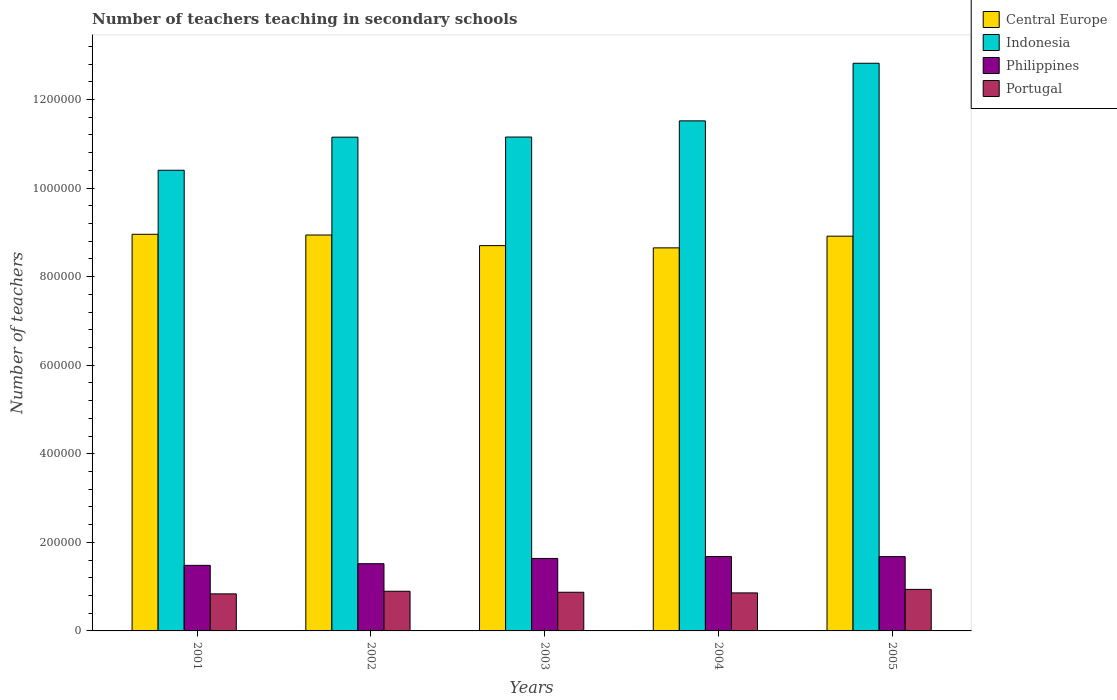How many different coloured bars are there?
Keep it short and to the point. 4. How many groups of bars are there?
Keep it short and to the point. 5. Are the number of bars per tick equal to the number of legend labels?
Your response must be concise. Yes. How many bars are there on the 1st tick from the left?
Give a very brief answer. 4. What is the number of teachers teaching in secondary schools in Indonesia in 2002?
Offer a terse response. 1.11e+06. Across all years, what is the maximum number of teachers teaching in secondary schools in Indonesia?
Your response must be concise. 1.28e+06. Across all years, what is the minimum number of teachers teaching in secondary schools in Philippines?
Keep it short and to the point. 1.48e+05. In which year was the number of teachers teaching in secondary schools in Portugal maximum?
Your answer should be very brief. 2005. In which year was the number of teachers teaching in secondary schools in Portugal minimum?
Your response must be concise. 2001. What is the total number of teachers teaching in secondary schools in Indonesia in the graph?
Make the answer very short. 5.70e+06. What is the difference between the number of teachers teaching in secondary schools in Philippines in 2003 and that in 2004?
Your answer should be compact. -4412. What is the difference between the number of teachers teaching in secondary schools in Philippines in 2003 and the number of teachers teaching in secondary schools in Indonesia in 2001?
Ensure brevity in your answer.  -8.76e+05. What is the average number of teachers teaching in secondary schools in Central Europe per year?
Provide a short and direct response. 8.83e+05. In the year 2001, what is the difference between the number of teachers teaching in secondary schools in Philippines and number of teachers teaching in secondary schools in Portugal?
Your answer should be compact. 6.44e+04. What is the ratio of the number of teachers teaching in secondary schools in Central Europe in 2001 to that in 2002?
Your response must be concise. 1. What is the difference between the highest and the second highest number of teachers teaching in secondary schools in Philippines?
Your answer should be compact. 309. What is the difference between the highest and the lowest number of teachers teaching in secondary schools in Indonesia?
Ensure brevity in your answer.  2.42e+05. In how many years, is the number of teachers teaching in secondary schools in Central Europe greater than the average number of teachers teaching in secondary schools in Central Europe taken over all years?
Ensure brevity in your answer.  3. What does the 1st bar from the left in 2005 represents?
Give a very brief answer. Central Europe. Is it the case that in every year, the sum of the number of teachers teaching in secondary schools in Portugal and number of teachers teaching in secondary schools in Philippines is greater than the number of teachers teaching in secondary schools in Central Europe?
Your response must be concise. No. Are all the bars in the graph horizontal?
Your response must be concise. No. Are the values on the major ticks of Y-axis written in scientific E-notation?
Offer a very short reply. No. Does the graph contain grids?
Make the answer very short. No. How many legend labels are there?
Offer a terse response. 4. What is the title of the graph?
Give a very brief answer. Number of teachers teaching in secondary schools. What is the label or title of the Y-axis?
Offer a very short reply. Number of teachers. What is the Number of teachers in Central Europe in 2001?
Offer a terse response. 8.96e+05. What is the Number of teachers of Indonesia in 2001?
Your answer should be compact. 1.04e+06. What is the Number of teachers in Philippines in 2001?
Your response must be concise. 1.48e+05. What is the Number of teachers in Portugal in 2001?
Offer a very short reply. 8.37e+04. What is the Number of teachers of Central Europe in 2002?
Your answer should be compact. 8.94e+05. What is the Number of teachers in Indonesia in 2002?
Offer a very short reply. 1.11e+06. What is the Number of teachers in Philippines in 2002?
Keep it short and to the point. 1.52e+05. What is the Number of teachers in Portugal in 2002?
Provide a short and direct response. 8.96e+04. What is the Number of teachers in Central Europe in 2003?
Your response must be concise. 8.70e+05. What is the Number of teachers of Indonesia in 2003?
Your answer should be very brief. 1.12e+06. What is the Number of teachers in Philippines in 2003?
Your answer should be very brief. 1.64e+05. What is the Number of teachers of Portugal in 2003?
Your answer should be very brief. 8.73e+04. What is the Number of teachers in Central Europe in 2004?
Offer a very short reply. 8.65e+05. What is the Number of teachers in Indonesia in 2004?
Provide a succinct answer. 1.15e+06. What is the Number of teachers of Philippines in 2004?
Offer a terse response. 1.68e+05. What is the Number of teachers in Portugal in 2004?
Your answer should be compact. 8.59e+04. What is the Number of teachers in Central Europe in 2005?
Ensure brevity in your answer.  8.91e+05. What is the Number of teachers of Indonesia in 2005?
Offer a very short reply. 1.28e+06. What is the Number of teachers in Philippines in 2005?
Make the answer very short. 1.68e+05. What is the Number of teachers of Portugal in 2005?
Keep it short and to the point. 9.38e+04. Across all years, what is the maximum Number of teachers in Central Europe?
Give a very brief answer. 8.96e+05. Across all years, what is the maximum Number of teachers of Indonesia?
Provide a succinct answer. 1.28e+06. Across all years, what is the maximum Number of teachers of Philippines?
Your response must be concise. 1.68e+05. Across all years, what is the maximum Number of teachers in Portugal?
Provide a short and direct response. 9.38e+04. Across all years, what is the minimum Number of teachers in Central Europe?
Give a very brief answer. 8.65e+05. Across all years, what is the minimum Number of teachers in Indonesia?
Offer a terse response. 1.04e+06. Across all years, what is the minimum Number of teachers of Philippines?
Make the answer very short. 1.48e+05. Across all years, what is the minimum Number of teachers of Portugal?
Offer a terse response. 8.37e+04. What is the total Number of teachers of Central Europe in the graph?
Give a very brief answer. 4.42e+06. What is the total Number of teachers in Indonesia in the graph?
Keep it short and to the point. 5.70e+06. What is the total Number of teachers of Philippines in the graph?
Provide a short and direct response. 7.99e+05. What is the total Number of teachers of Portugal in the graph?
Your answer should be compact. 4.40e+05. What is the difference between the Number of teachers in Central Europe in 2001 and that in 2002?
Your response must be concise. 1627.56. What is the difference between the Number of teachers of Indonesia in 2001 and that in 2002?
Your answer should be compact. -7.47e+04. What is the difference between the Number of teachers of Philippines in 2001 and that in 2002?
Provide a succinct answer. -3717. What is the difference between the Number of teachers of Portugal in 2001 and that in 2002?
Offer a very short reply. -5935. What is the difference between the Number of teachers in Central Europe in 2001 and that in 2003?
Ensure brevity in your answer.  2.56e+04. What is the difference between the Number of teachers of Indonesia in 2001 and that in 2003?
Offer a very short reply. -7.50e+04. What is the difference between the Number of teachers in Philippines in 2001 and that in 2003?
Offer a very short reply. -1.56e+04. What is the difference between the Number of teachers of Portugal in 2001 and that in 2003?
Ensure brevity in your answer.  -3651. What is the difference between the Number of teachers in Central Europe in 2001 and that in 2004?
Offer a very short reply. 3.07e+04. What is the difference between the Number of teachers in Indonesia in 2001 and that in 2004?
Provide a short and direct response. -1.12e+05. What is the difference between the Number of teachers of Philippines in 2001 and that in 2004?
Provide a short and direct response. -2.00e+04. What is the difference between the Number of teachers of Portugal in 2001 and that in 2004?
Offer a terse response. -2207. What is the difference between the Number of teachers in Central Europe in 2001 and that in 2005?
Ensure brevity in your answer.  4228.88. What is the difference between the Number of teachers of Indonesia in 2001 and that in 2005?
Offer a very short reply. -2.42e+05. What is the difference between the Number of teachers in Philippines in 2001 and that in 2005?
Your answer should be very brief. -1.97e+04. What is the difference between the Number of teachers of Portugal in 2001 and that in 2005?
Offer a very short reply. -1.02e+04. What is the difference between the Number of teachers in Central Europe in 2002 and that in 2003?
Provide a short and direct response. 2.40e+04. What is the difference between the Number of teachers in Indonesia in 2002 and that in 2003?
Keep it short and to the point. -300. What is the difference between the Number of teachers of Philippines in 2002 and that in 2003?
Your response must be concise. -1.19e+04. What is the difference between the Number of teachers of Portugal in 2002 and that in 2003?
Your answer should be very brief. 2284. What is the difference between the Number of teachers of Central Europe in 2002 and that in 2004?
Make the answer very short. 2.90e+04. What is the difference between the Number of teachers of Indonesia in 2002 and that in 2004?
Your answer should be very brief. -3.68e+04. What is the difference between the Number of teachers of Philippines in 2002 and that in 2004?
Give a very brief answer. -1.63e+04. What is the difference between the Number of teachers of Portugal in 2002 and that in 2004?
Provide a succinct answer. 3728. What is the difference between the Number of teachers of Central Europe in 2002 and that in 2005?
Keep it short and to the point. 2601.31. What is the difference between the Number of teachers of Indonesia in 2002 and that in 2005?
Keep it short and to the point. -1.67e+05. What is the difference between the Number of teachers of Philippines in 2002 and that in 2005?
Your response must be concise. -1.60e+04. What is the difference between the Number of teachers of Portugal in 2002 and that in 2005?
Provide a succinct answer. -4217. What is the difference between the Number of teachers in Central Europe in 2003 and that in 2004?
Make the answer very short. 5052.31. What is the difference between the Number of teachers of Indonesia in 2003 and that in 2004?
Your answer should be compact. -3.65e+04. What is the difference between the Number of teachers of Philippines in 2003 and that in 2004?
Keep it short and to the point. -4412. What is the difference between the Number of teachers in Portugal in 2003 and that in 2004?
Your answer should be very brief. 1444. What is the difference between the Number of teachers of Central Europe in 2003 and that in 2005?
Keep it short and to the point. -2.14e+04. What is the difference between the Number of teachers in Indonesia in 2003 and that in 2005?
Provide a short and direct response. -1.67e+05. What is the difference between the Number of teachers of Philippines in 2003 and that in 2005?
Offer a terse response. -4103. What is the difference between the Number of teachers of Portugal in 2003 and that in 2005?
Offer a terse response. -6501. What is the difference between the Number of teachers in Central Europe in 2004 and that in 2005?
Your response must be concise. -2.64e+04. What is the difference between the Number of teachers of Indonesia in 2004 and that in 2005?
Your answer should be very brief. -1.30e+05. What is the difference between the Number of teachers of Philippines in 2004 and that in 2005?
Provide a short and direct response. 309. What is the difference between the Number of teachers in Portugal in 2004 and that in 2005?
Offer a very short reply. -7945. What is the difference between the Number of teachers of Central Europe in 2001 and the Number of teachers of Indonesia in 2002?
Provide a succinct answer. -2.19e+05. What is the difference between the Number of teachers in Central Europe in 2001 and the Number of teachers in Philippines in 2002?
Provide a succinct answer. 7.44e+05. What is the difference between the Number of teachers in Central Europe in 2001 and the Number of teachers in Portugal in 2002?
Provide a succinct answer. 8.06e+05. What is the difference between the Number of teachers of Indonesia in 2001 and the Number of teachers of Philippines in 2002?
Ensure brevity in your answer.  8.88e+05. What is the difference between the Number of teachers in Indonesia in 2001 and the Number of teachers in Portugal in 2002?
Offer a very short reply. 9.50e+05. What is the difference between the Number of teachers of Philippines in 2001 and the Number of teachers of Portugal in 2002?
Offer a very short reply. 5.84e+04. What is the difference between the Number of teachers in Central Europe in 2001 and the Number of teachers in Indonesia in 2003?
Your response must be concise. -2.20e+05. What is the difference between the Number of teachers in Central Europe in 2001 and the Number of teachers in Philippines in 2003?
Your answer should be compact. 7.32e+05. What is the difference between the Number of teachers of Central Europe in 2001 and the Number of teachers of Portugal in 2003?
Keep it short and to the point. 8.08e+05. What is the difference between the Number of teachers of Indonesia in 2001 and the Number of teachers of Philippines in 2003?
Provide a short and direct response. 8.76e+05. What is the difference between the Number of teachers in Indonesia in 2001 and the Number of teachers in Portugal in 2003?
Keep it short and to the point. 9.53e+05. What is the difference between the Number of teachers of Philippines in 2001 and the Number of teachers of Portugal in 2003?
Your answer should be very brief. 6.07e+04. What is the difference between the Number of teachers in Central Europe in 2001 and the Number of teachers in Indonesia in 2004?
Ensure brevity in your answer.  -2.56e+05. What is the difference between the Number of teachers of Central Europe in 2001 and the Number of teachers of Philippines in 2004?
Give a very brief answer. 7.27e+05. What is the difference between the Number of teachers of Central Europe in 2001 and the Number of teachers of Portugal in 2004?
Your answer should be very brief. 8.10e+05. What is the difference between the Number of teachers in Indonesia in 2001 and the Number of teachers in Philippines in 2004?
Your answer should be compact. 8.72e+05. What is the difference between the Number of teachers of Indonesia in 2001 and the Number of teachers of Portugal in 2004?
Ensure brevity in your answer.  9.54e+05. What is the difference between the Number of teachers of Philippines in 2001 and the Number of teachers of Portugal in 2004?
Keep it short and to the point. 6.22e+04. What is the difference between the Number of teachers of Central Europe in 2001 and the Number of teachers of Indonesia in 2005?
Your answer should be very brief. -3.86e+05. What is the difference between the Number of teachers of Central Europe in 2001 and the Number of teachers of Philippines in 2005?
Ensure brevity in your answer.  7.28e+05. What is the difference between the Number of teachers of Central Europe in 2001 and the Number of teachers of Portugal in 2005?
Give a very brief answer. 8.02e+05. What is the difference between the Number of teachers of Indonesia in 2001 and the Number of teachers of Philippines in 2005?
Provide a short and direct response. 8.72e+05. What is the difference between the Number of teachers of Indonesia in 2001 and the Number of teachers of Portugal in 2005?
Your answer should be compact. 9.46e+05. What is the difference between the Number of teachers of Philippines in 2001 and the Number of teachers of Portugal in 2005?
Make the answer very short. 5.42e+04. What is the difference between the Number of teachers of Central Europe in 2002 and the Number of teachers of Indonesia in 2003?
Offer a terse response. -2.21e+05. What is the difference between the Number of teachers in Central Europe in 2002 and the Number of teachers in Philippines in 2003?
Offer a terse response. 7.30e+05. What is the difference between the Number of teachers of Central Europe in 2002 and the Number of teachers of Portugal in 2003?
Offer a very short reply. 8.07e+05. What is the difference between the Number of teachers of Indonesia in 2002 and the Number of teachers of Philippines in 2003?
Provide a succinct answer. 9.51e+05. What is the difference between the Number of teachers in Indonesia in 2002 and the Number of teachers in Portugal in 2003?
Offer a terse response. 1.03e+06. What is the difference between the Number of teachers in Philippines in 2002 and the Number of teachers in Portugal in 2003?
Provide a short and direct response. 6.44e+04. What is the difference between the Number of teachers in Central Europe in 2002 and the Number of teachers in Indonesia in 2004?
Provide a short and direct response. -2.58e+05. What is the difference between the Number of teachers in Central Europe in 2002 and the Number of teachers in Philippines in 2004?
Ensure brevity in your answer.  7.26e+05. What is the difference between the Number of teachers of Central Europe in 2002 and the Number of teachers of Portugal in 2004?
Offer a terse response. 8.08e+05. What is the difference between the Number of teachers of Indonesia in 2002 and the Number of teachers of Philippines in 2004?
Offer a very short reply. 9.47e+05. What is the difference between the Number of teachers in Indonesia in 2002 and the Number of teachers in Portugal in 2004?
Make the answer very short. 1.03e+06. What is the difference between the Number of teachers in Philippines in 2002 and the Number of teachers in Portugal in 2004?
Give a very brief answer. 6.59e+04. What is the difference between the Number of teachers in Central Europe in 2002 and the Number of teachers in Indonesia in 2005?
Your answer should be very brief. -3.88e+05. What is the difference between the Number of teachers of Central Europe in 2002 and the Number of teachers of Philippines in 2005?
Give a very brief answer. 7.26e+05. What is the difference between the Number of teachers of Central Europe in 2002 and the Number of teachers of Portugal in 2005?
Your response must be concise. 8.00e+05. What is the difference between the Number of teachers in Indonesia in 2002 and the Number of teachers in Philippines in 2005?
Your answer should be compact. 9.47e+05. What is the difference between the Number of teachers in Indonesia in 2002 and the Number of teachers in Portugal in 2005?
Offer a very short reply. 1.02e+06. What is the difference between the Number of teachers in Philippines in 2002 and the Number of teachers in Portugal in 2005?
Provide a succinct answer. 5.79e+04. What is the difference between the Number of teachers in Central Europe in 2003 and the Number of teachers in Indonesia in 2004?
Give a very brief answer. -2.82e+05. What is the difference between the Number of teachers in Central Europe in 2003 and the Number of teachers in Philippines in 2004?
Make the answer very short. 7.02e+05. What is the difference between the Number of teachers of Central Europe in 2003 and the Number of teachers of Portugal in 2004?
Ensure brevity in your answer.  7.84e+05. What is the difference between the Number of teachers in Indonesia in 2003 and the Number of teachers in Philippines in 2004?
Offer a terse response. 9.47e+05. What is the difference between the Number of teachers in Indonesia in 2003 and the Number of teachers in Portugal in 2004?
Your answer should be very brief. 1.03e+06. What is the difference between the Number of teachers in Philippines in 2003 and the Number of teachers in Portugal in 2004?
Give a very brief answer. 7.78e+04. What is the difference between the Number of teachers in Central Europe in 2003 and the Number of teachers in Indonesia in 2005?
Make the answer very short. -4.12e+05. What is the difference between the Number of teachers of Central Europe in 2003 and the Number of teachers of Philippines in 2005?
Your response must be concise. 7.02e+05. What is the difference between the Number of teachers of Central Europe in 2003 and the Number of teachers of Portugal in 2005?
Provide a succinct answer. 7.76e+05. What is the difference between the Number of teachers in Indonesia in 2003 and the Number of teachers in Philippines in 2005?
Offer a terse response. 9.47e+05. What is the difference between the Number of teachers of Indonesia in 2003 and the Number of teachers of Portugal in 2005?
Offer a terse response. 1.02e+06. What is the difference between the Number of teachers of Philippines in 2003 and the Number of teachers of Portugal in 2005?
Provide a short and direct response. 6.98e+04. What is the difference between the Number of teachers of Central Europe in 2004 and the Number of teachers of Indonesia in 2005?
Provide a succinct answer. -4.17e+05. What is the difference between the Number of teachers of Central Europe in 2004 and the Number of teachers of Philippines in 2005?
Your answer should be very brief. 6.97e+05. What is the difference between the Number of teachers in Central Europe in 2004 and the Number of teachers in Portugal in 2005?
Keep it short and to the point. 7.71e+05. What is the difference between the Number of teachers of Indonesia in 2004 and the Number of teachers of Philippines in 2005?
Your answer should be very brief. 9.84e+05. What is the difference between the Number of teachers in Indonesia in 2004 and the Number of teachers in Portugal in 2005?
Your answer should be very brief. 1.06e+06. What is the difference between the Number of teachers of Philippines in 2004 and the Number of teachers of Portugal in 2005?
Offer a terse response. 7.43e+04. What is the average Number of teachers in Central Europe per year?
Offer a terse response. 8.83e+05. What is the average Number of teachers of Indonesia per year?
Your response must be concise. 1.14e+06. What is the average Number of teachers of Philippines per year?
Your response must be concise. 1.60e+05. What is the average Number of teachers of Portugal per year?
Ensure brevity in your answer.  8.80e+04. In the year 2001, what is the difference between the Number of teachers in Central Europe and Number of teachers in Indonesia?
Offer a terse response. -1.45e+05. In the year 2001, what is the difference between the Number of teachers of Central Europe and Number of teachers of Philippines?
Your answer should be compact. 7.47e+05. In the year 2001, what is the difference between the Number of teachers of Central Europe and Number of teachers of Portugal?
Ensure brevity in your answer.  8.12e+05. In the year 2001, what is the difference between the Number of teachers in Indonesia and Number of teachers in Philippines?
Make the answer very short. 8.92e+05. In the year 2001, what is the difference between the Number of teachers in Indonesia and Number of teachers in Portugal?
Ensure brevity in your answer.  9.56e+05. In the year 2001, what is the difference between the Number of teachers in Philippines and Number of teachers in Portugal?
Your response must be concise. 6.44e+04. In the year 2002, what is the difference between the Number of teachers of Central Europe and Number of teachers of Indonesia?
Provide a short and direct response. -2.21e+05. In the year 2002, what is the difference between the Number of teachers in Central Europe and Number of teachers in Philippines?
Offer a very short reply. 7.42e+05. In the year 2002, what is the difference between the Number of teachers in Central Europe and Number of teachers in Portugal?
Make the answer very short. 8.04e+05. In the year 2002, what is the difference between the Number of teachers in Indonesia and Number of teachers in Philippines?
Keep it short and to the point. 9.63e+05. In the year 2002, what is the difference between the Number of teachers in Indonesia and Number of teachers in Portugal?
Offer a terse response. 1.03e+06. In the year 2002, what is the difference between the Number of teachers of Philippines and Number of teachers of Portugal?
Offer a terse response. 6.22e+04. In the year 2003, what is the difference between the Number of teachers in Central Europe and Number of teachers in Indonesia?
Your answer should be compact. -2.45e+05. In the year 2003, what is the difference between the Number of teachers of Central Europe and Number of teachers of Philippines?
Your answer should be very brief. 7.06e+05. In the year 2003, what is the difference between the Number of teachers in Central Europe and Number of teachers in Portugal?
Give a very brief answer. 7.83e+05. In the year 2003, what is the difference between the Number of teachers of Indonesia and Number of teachers of Philippines?
Offer a very short reply. 9.51e+05. In the year 2003, what is the difference between the Number of teachers in Indonesia and Number of teachers in Portugal?
Your answer should be compact. 1.03e+06. In the year 2003, what is the difference between the Number of teachers in Philippines and Number of teachers in Portugal?
Offer a terse response. 7.63e+04. In the year 2004, what is the difference between the Number of teachers of Central Europe and Number of teachers of Indonesia?
Ensure brevity in your answer.  -2.87e+05. In the year 2004, what is the difference between the Number of teachers of Central Europe and Number of teachers of Philippines?
Offer a very short reply. 6.97e+05. In the year 2004, what is the difference between the Number of teachers in Central Europe and Number of teachers in Portugal?
Offer a terse response. 7.79e+05. In the year 2004, what is the difference between the Number of teachers in Indonesia and Number of teachers in Philippines?
Give a very brief answer. 9.84e+05. In the year 2004, what is the difference between the Number of teachers of Indonesia and Number of teachers of Portugal?
Give a very brief answer. 1.07e+06. In the year 2004, what is the difference between the Number of teachers in Philippines and Number of teachers in Portugal?
Keep it short and to the point. 8.22e+04. In the year 2005, what is the difference between the Number of teachers of Central Europe and Number of teachers of Indonesia?
Offer a very short reply. -3.90e+05. In the year 2005, what is the difference between the Number of teachers of Central Europe and Number of teachers of Philippines?
Offer a very short reply. 7.24e+05. In the year 2005, what is the difference between the Number of teachers in Central Europe and Number of teachers in Portugal?
Provide a succinct answer. 7.97e+05. In the year 2005, what is the difference between the Number of teachers in Indonesia and Number of teachers in Philippines?
Provide a short and direct response. 1.11e+06. In the year 2005, what is the difference between the Number of teachers of Indonesia and Number of teachers of Portugal?
Make the answer very short. 1.19e+06. In the year 2005, what is the difference between the Number of teachers of Philippines and Number of teachers of Portugal?
Make the answer very short. 7.39e+04. What is the ratio of the Number of teachers of Central Europe in 2001 to that in 2002?
Your answer should be very brief. 1. What is the ratio of the Number of teachers of Indonesia in 2001 to that in 2002?
Keep it short and to the point. 0.93. What is the ratio of the Number of teachers of Philippines in 2001 to that in 2002?
Your answer should be very brief. 0.98. What is the ratio of the Number of teachers in Portugal in 2001 to that in 2002?
Give a very brief answer. 0.93. What is the ratio of the Number of teachers in Central Europe in 2001 to that in 2003?
Your response must be concise. 1.03. What is the ratio of the Number of teachers of Indonesia in 2001 to that in 2003?
Provide a succinct answer. 0.93. What is the ratio of the Number of teachers in Philippines in 2001 to that in 2003?
Ensure brevity in your answer.  0.9. What is the ratio of the Number of teachers of Portugal in 2001 to that in 2003?
Your response must be concise. 0.96. What is the ratio of the Number of teachers of Central Europe in 2001 to that in 2004?
Provide a succinct answer. 1.04. What is the ratio of the Number of teachers in Indonesia in 2001 to that in 2004?
Provide a short and direct response. 0.9. What is the ratio of the Number of teachers of Philippines in 2001 to that in 2004?
Provide a succinct answer. 0.88. What is the ratio of the Number of teachers in Portugal in 2001 to that in 2004?
Provide a short and direct response. 0.97. What is the ratio of the Number of teachers of Indonesia in 2001 to that in 2005?
Provide a short and direct response. 0.81. What is the ratio of the Number of teachers of Philippines in 2001 to that in 2005?
Offer a very short reply. 0.88. What is the ratio of the Number of teachers in Portugal in 2001 to that in 2005?
Your answer should be compact. 0.89. What is the ratio of the Number of teachers in Central Europe in 2002 to that in 2003?
Your response must be concise. 1.03. What is the ratio of the Number of teachers in Philippines in 2002 to that in 2003?
Your answer should be very brief. 0.93. What is the ratio of the Number of teachers in Portugal in 2002 to that in 2003?
Give a very brief answer. 1.03. What is the ratio of the Number of teachers of Central Europe in 2002 to that in 2004?
Ensure brevity in your answer.  1.03. What is the ratio of the Number of teachers of Philippines in 2002 to that in 2004?
Ensure brevity in your answer.  0.9. What is the ratio of the Number of teachers of Portugal in 2002 to that in 2004?
Your response must be concise. 1.04. What is the ratio of the Number of teachers of Central Europe in 2002 to that in 2005?
Ensure brevity in your answer.  1. What is the ratio of the Number of teachers of Indonesia in 2002 to that in 2005?
Keep it short and to the point. 0.87. What is the ratio of the Number of teachers in Philippines in 2002 to that in 2005?
Keep it short and to the point. 0.9. What is the ratio of the Number of teachers of Portugal in 2002 to that in 2005?
Your answer should be very brief. 0.95. What is the ratio of the Number of teachers of Central Europe in 2003 to that in 2004?
Make the answer very short. 1.01. What is the ratio of the Number of teachers of Indonesia in 2003 to that in 2004?
Your answer should be very brief. 0.97. What is the ratio of the Number of teachers of Philippines in 2003 to that in 2004?
Keep it short and to the point. 0.97. What is the ratio of the Number of teachers of Portugal in 2003 to that in 2004?
Give a very brief answer. 1.02. What is the ratio of the Number of teachers in Indonesia in 2003 to that in 2005?
Your answer should be compact. 0.87. What is the ratio of the Number of teachers of Philippines in 2003 to that in 2005?
Offer a very short reply. 0.98. What is the ratio of the Number of teachers in Portugal in 2003 to that in 2005?
Provide a short and direct response. 0.93. What is the ratio of the Number of teachers in Central Europe in 2004 to that in 2005?
Offer a very short reply. 0.97. What is the ratio of the Number of teachers of Indonesia in 2004 to that in 2005?
Provide a succinct answer. 0.9. What is the ratio of the Number of teachers of Philippines in 2004 to that in 2005?
Offer a terse response. 1. What is the ratio of the Number of teachers in Portugal in 2004 to that in 2005?
Provide a short and direct response. 0.92. What is the difference between the highest and the second highest Number of teachers of Central Europe?
Offer a terse response. 1627.56. What is the difference between the highest and the second highest Number of teachers in Indonesia?
Your answer should be very brief. 1.30e+05. What is the difference between the highest and the second highest Number of teachers in Philippines?
Ensure brevity in your answer.  309. What is the difference between the highest and the second highest Number of teachers in Portugal?
Make the answer very short. 4217. What is the difference between the highest and the lowest Number of teachers in Central Europe?
Offer a terse response. 3.07e+04. What is the difference between the highest and the lowest Number of teachers of Indonesia?
Make the answer very short. 2.42e+05. What is the difference between the highest and the lowest Number of teachers of Philippines?
Give a very brief answer. 2.00e+04. What is the difference between the highest and the lowest Number of teachers in Portugal?
Make the answer very short. 1.02e+04. 